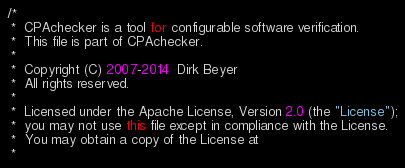<code> <loc_0><loc_0><loc_500><loc_500><_Java_>/*
 *  CPAchecker is a tool for configurable software verification.
 *  This file is part of CPAchecker.
 *
 *  Copyright (C) 2007-2014  Dirk Beyer
 *  All rights reserved.
 *
 *  Licensed under the Apache License, Version 2.0 (the "License");
 *  you may not use this file except in compliance with the License.
 *  You may obtain a copy of the License at
 *</code> 